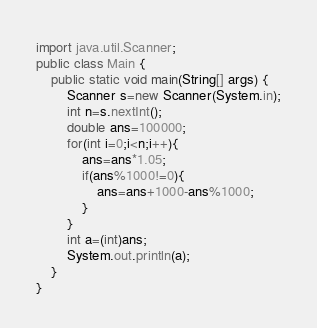Convert code to text. <code><loc_0><loc_0><loc_500><loc_500><_Java_>import java.util.Scanner;
public class Main {
	public static void main(String[] args) {
		Scanner s=new Scanner(System.in);
		int n=s.nextInt();
		double ans=100000;
		for(int i=0;i<n;i++){
			ans=ans*1.05;
			if(ans%1000!=0){
				ans=ans+1000-ans%1000;
			}
		}
		int a=(int)ans;
		System.out.println(a);
	}
}</code> 